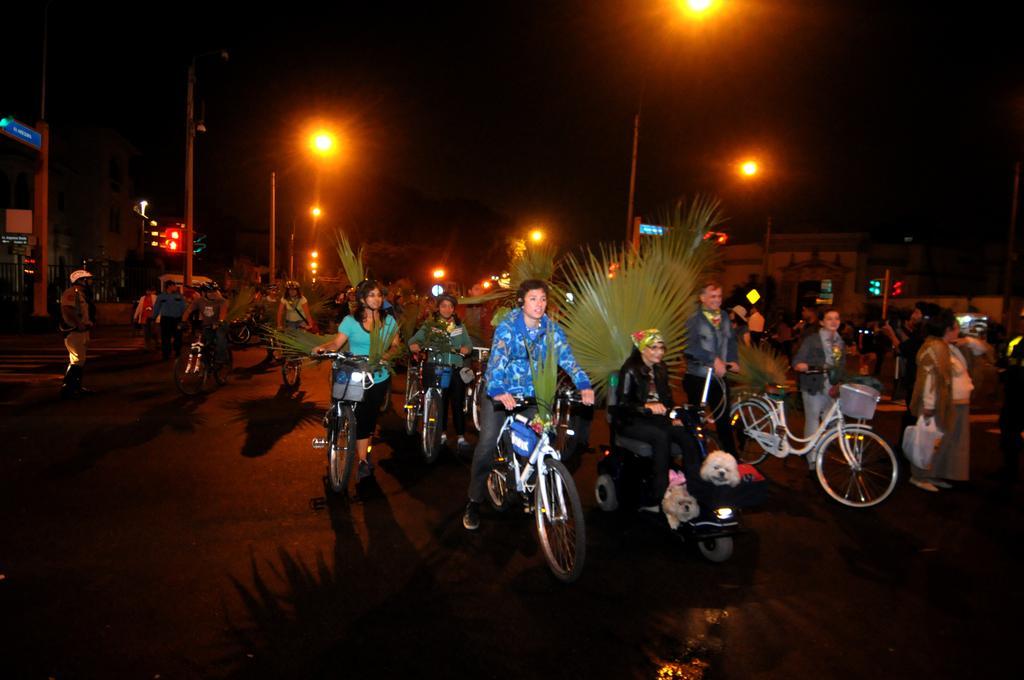Describe this image in one or two sentences. In this image there are a few people riding a bicycle, a few are walking and holding the handle of a bicycle. In the background there are a few street lights and buildings. 